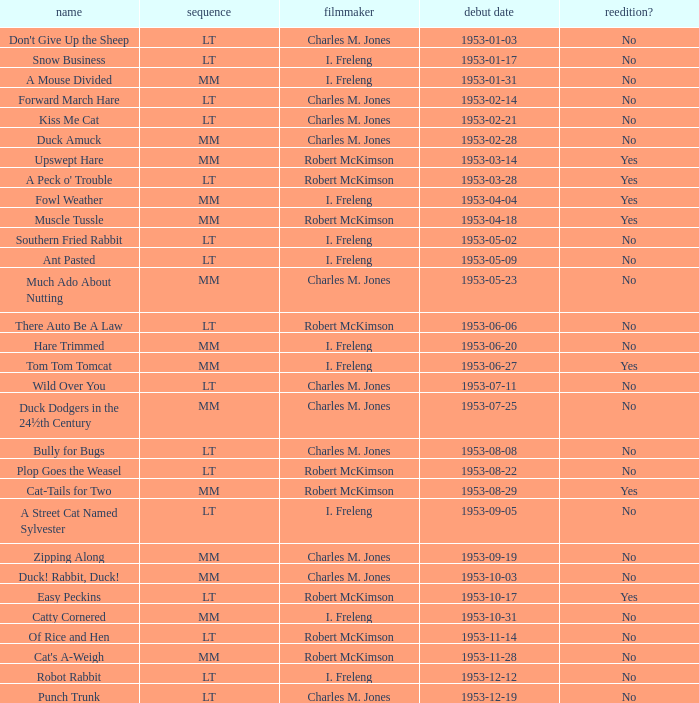Was there a reissue of the film released on 1953-10-03? No. 